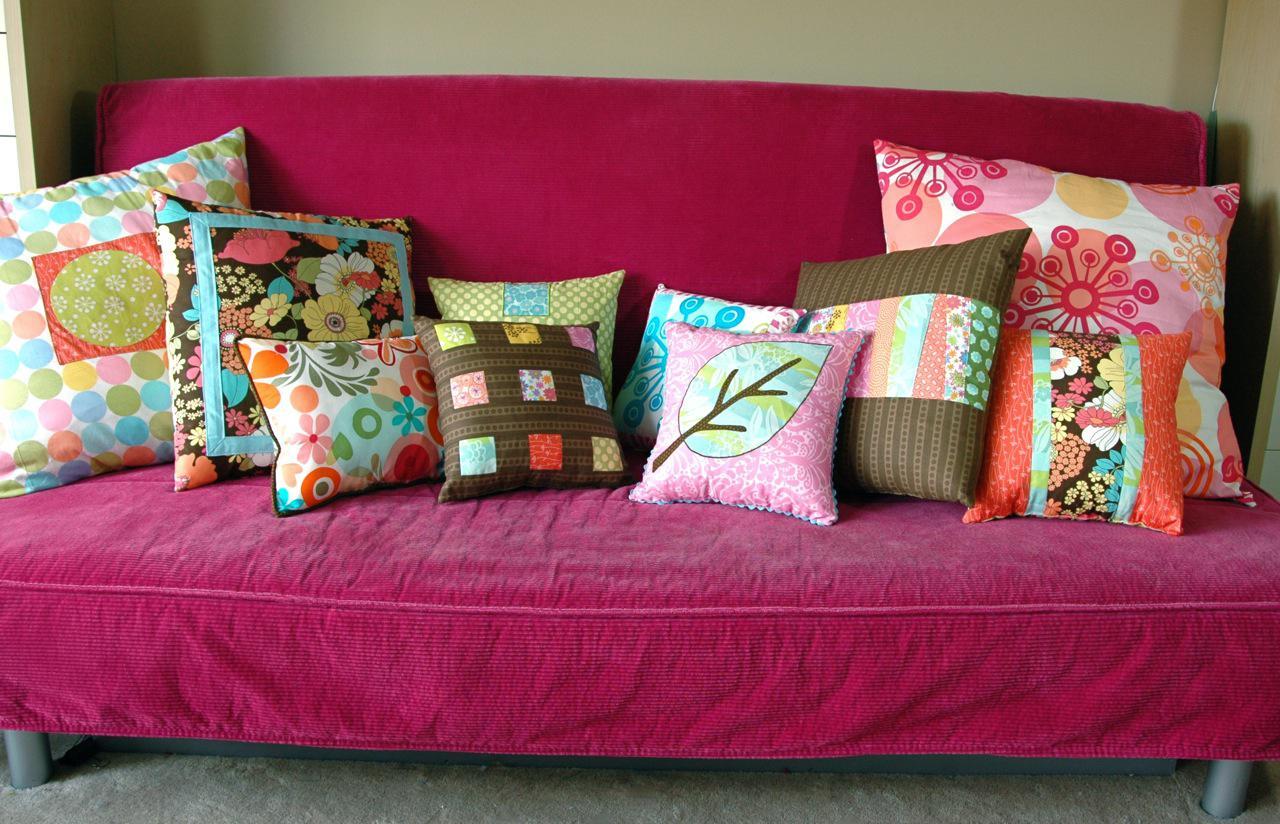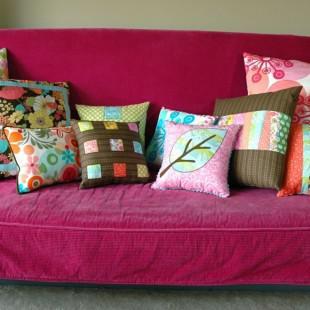The first image is the image on the left, the second image is the image on the right. For the images displayed, is the sentence "At least one of the sofas is a solid pink color." factually correct? Answer yes or no. Yes. 